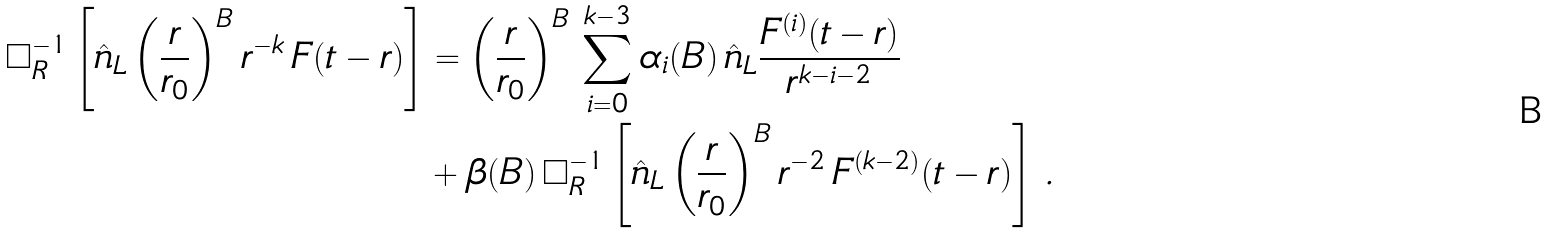Convert formula to latex. <formula><loc_0><loc_0><loc_500><loc_500>\Box ^ { - 1 } _ { R } \left [ \hat { n } _ { L } \left ( \frac { r } { r _ { 0 } } \right ) ^ { B } r ^ { - k } \, F ( t - r ) \right ] & = \left ( \frac { r } { r _ { 0 } } \right ) ^ { B } \, \sum _ { i = 0 } ^ { k - 3 } \alpha _ { i } ( B ) \, \hat { n } _ { L } \frac { F ^ { ( i ) } ( t - r ) } { r ^ { k - i - 2 } } \\ & + \beta ( B ) \, \Box ^ { - 1 } _ { R } \left [ \hat { n } _ { L } \left ( \frac { r } { r _ { 0 } } \right ) ^ { B } r ^ { - 2 } \, F ^ { ( k - 2 ) } ( t - r ) \right ] \, .</formula> 